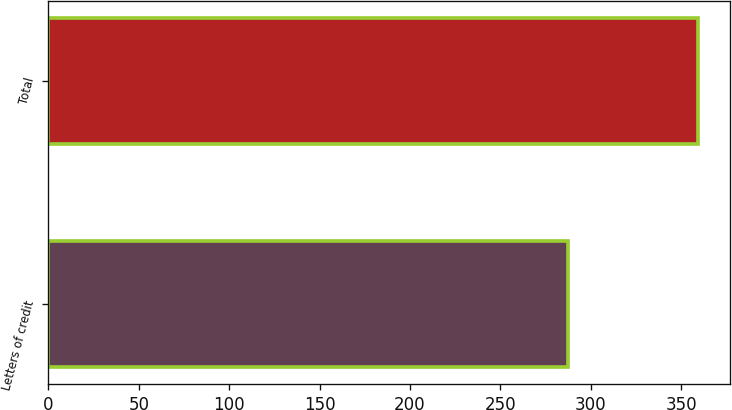<chart> <loc_0><loc_0><loc_500><loc_500><bar_chart><fcel>Letters of credit<fcel>Total<nl><fcel>287.2<fcel>359.1<nl></chart> 